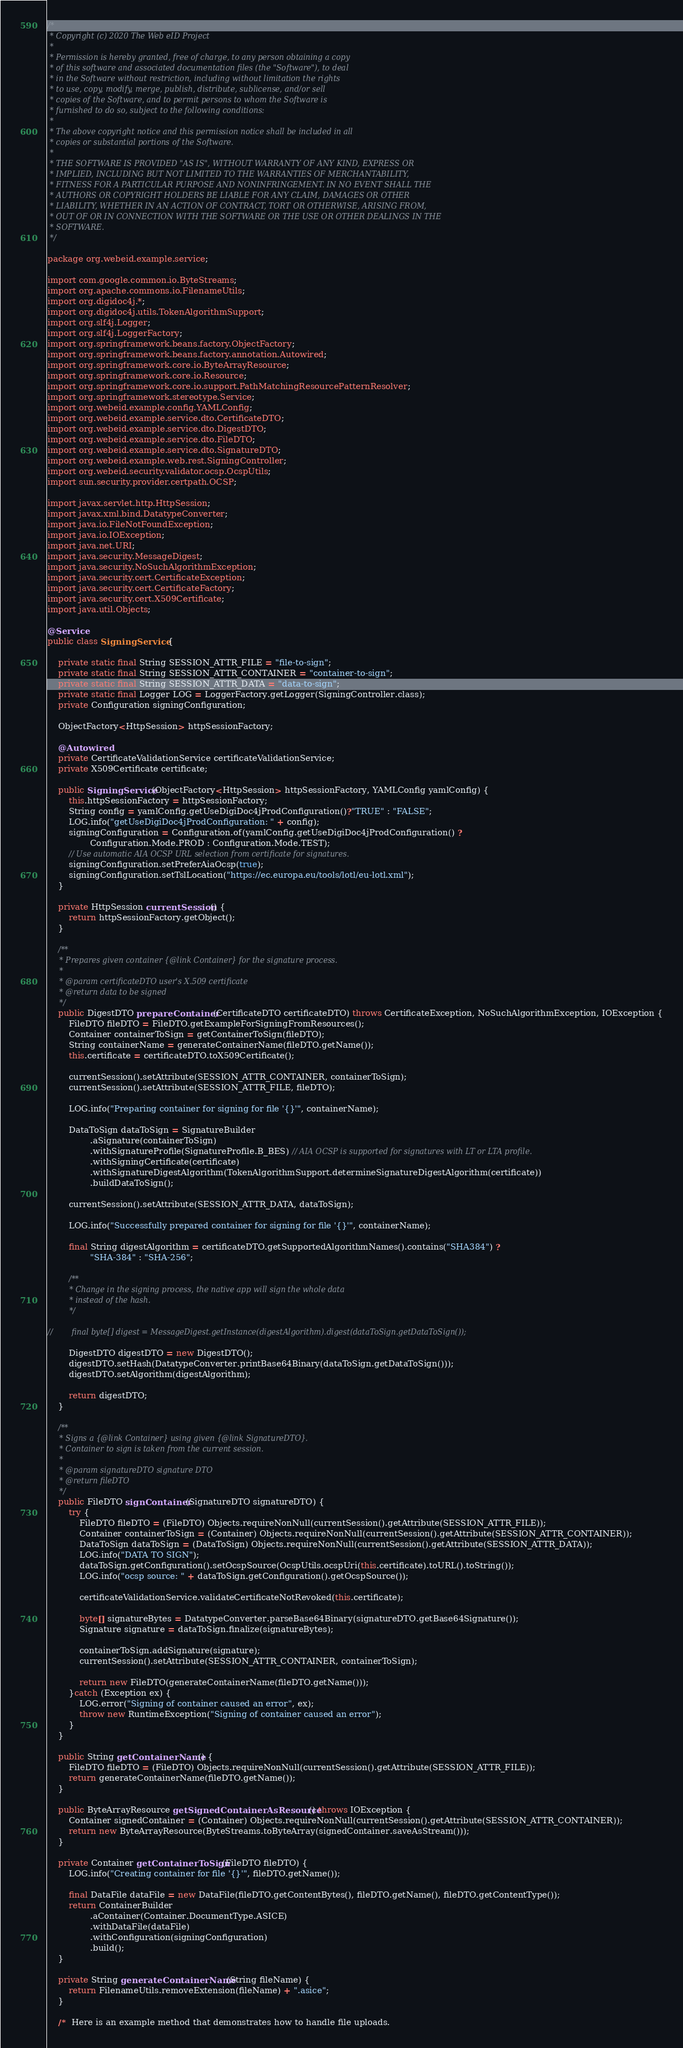<code> <loc_0><loc_0><loc_500><loc_500><_Java_>/*
 * Copyright (c) 2020 The Web eID Project
 *
 * Permission is hereby granted, free of charge, to any person obtaining a copy
 * of this software and associated documentation files (the "Software"), to deal
 * in the Software without restriction, including without limitation the rights
 * to use, copy, modify, merge, publish, distribute, sublicense, and/or sell
 * copies of the Software, and to permit persons to whom the Software is
 * furnished to do so, subject to the following conditions:
 *
 * The above copyright notice and this permission notice shall be included in all
 * copies or substantial portions of the Software.
 *
 * THE SOFTWARE IS PROVIDED "AS IS", WITHOUT WARRANTY OF ANY KIND, EXPRESS OR
 * IMPLIED, INCLUDING BUT NOT LIMITED TO THE WARRANTIES OF MERCHANTABILITY,
 * FITNESS FOR A PARTICULAR PURPOSE AND NONINFRINGEMENT. IN NO EVENT SHALL THE
 * AUTHORS OR COPYRIGHT HOLDERS BE LIABLE FOR ANY CLAIM, DAMAGES OR OTHER
 * LIABILITY, WHETHER IN AN ACTION OF CONTRACT, TORT OR OTHERWISE, ARISING FROM,
 * OUT OF OR IN CONNECTION WITH THE SOFTWARE OR THE USE OR OTHER DEALINGS IN THE
 * SOFTWARE.
 */

package org.webeid.example.service;

import com.google.common.io.ByteStreams;
import org.apache.commons.io.FilenameUtils;
import org.digidoc4j.*;
import org.digidoc4j.utils.TokenAlgorithmSupport;
import org.slf4j.Logger;
import org.slf4j.LoggerFactory;
import org.springframework.beans.factory.ObjectFactory;
import org.springframework.beans.factory.annotation.Autowired;
import org.springframework.core.io.ByteArrayResource;
import org.springframework.core.io.Resource;
import org.springframework.core.io.support.PathMatchingResourcePatternResolver;
import org.springframework.stereotype.Service;
import org.webeid.example.config.YAMLConfig;
import org.webeid.example.service.dto.CertificateDTO;
import org.webeid.example.service.dto.DigestDTO;
import org.webeid.example.service.dto.FileDTO;
import org.webeid.example.service.dto.SignatureDTO;
import org.webeid.example.web.rest.SigningController;
import org.webeid.security.validator.ocsp.OcspUtils;
import sun.security.provider.certpath.OCSP;

import javax.servlet.http.HttpSession;
import javax.xml.bind.DatatypeConverter;
import java.io.FileNotFoundException;
import java.io.IOException;
import java.net.URI;
import java.security.MessageDigest;
import java.security.NoSuchAlgorithmException;
import java.security.cert.CertificateException;
import java.security.cert.CertificateFactory;
import java.security.cert.X509Certificate;
import java.util.Objects;

@Service
public class SigningService {

    private static final String SESSION_ATTR_FILE = "file-to-sign";
    private static final String SESSION_ATTR_CONTAINER = "container-to-sign";
    private static final String SESSION_ATTR_DATA = "data-to-sign";
    private static final Logger LOG = LoggerFactory.getLogger(SigningController.class);
    private Configuration signingConfiguration;

    ObjectFactory<HttpSession> httpSessionFactory;

    @Autowired
    private CertificateValidationService certificateValidationService;
    private X509Certificate certificate;

    public SigningService(ObjectFactory<HttpSession> httpSessionFactory, YAMLConfig yamlConfig) {
        this.httpSessionFactory = httpSessionFactory;
        String config = yamlConfig.getUseDigiDoc4jProdConfiguration()?"TRUE" : "FALSE";
        LOG.info("getUseDigiDoc4jProdConfiguration: " + config);
        signingConfiguration = Configuration.of(yamlConfig.getUseDigiDoc4jProdConfiguration() ?
                Configuration.Mode.PROD : Configuration.Mode.TEST);
        // Use automatic AIA OCSP URL selection from certificate for signatures.
        signingConfiguration.setPreferAiaOcsp(true);
        signingConfiguration.setTslLocation("https://ec.europa.eu/tools/lotl/eu-lotl.xml");
    }

    private HttpSession currentSession() {
        return httpSessionFactory.getObject();
    }

    /**
     * Prepares given container {@link Container} for the signature process.
     *
     * @param certificateDTO user's X.509 certificate
     * @return data to be signed
     */
    public DigestDTO prepareContainer(CertificateDTO certificateDTO) throws CertificateException, NoSuchAlgorithmException, IOException {
        FileDTO fileDTO = FileDTO.getExampleForSigningFromResources();
        Container containerToSign = getContainerToSign(fileDTO);
        String containerName = generateContainerName(fileDTO.getName());
        this.certificate = certificateDTO.toX509Certificate();

        currentSession().setAttribute(SESSION_ATTR_CONTAINER, containerToSign);
        currentSession().setAttribute(SESSION_ATTR_FILE, fileDTO);

        LOG.info("Preparing container for signing for file '{}'", containerName);

        DataToSign dataToSign = SignatureBuilder
                .aSignature(containerToSign)
                .withSignatureProfile(SignatureProfile.B_BES) // AIA OCSP is supported for signatures with LT or LTA profile.
                .withSigningCertificate(certificate)
                .withSignatureDigestAlgorithm(TokenAlgorithmSupport.determineSignatureDigestAlgorithm(certificate))
                .buildDataToSign();

        currentSession().setAttribute(SESSION_ATTR_DATA, dataToSign);

        LOG.info("Successfully prepared container for signing for file '{}'", containerName);

        final String digestAlgorithm = certificateDTO.getSupportedAlgorithmNames().contains("SHA384") ?
                "SHA-384" : "SHA-256";

        /**
         * Change in the signing process, the native app will sign the whole data
         * instead of the hash.
         */

//        final byte[] digest = MessageDigest.getInstance(digestAlgorithm).digest(dataToSign.getDataToSign());

        DigestDTO digestDTO = new DigestDTO();
        digestDTO.setHash(DatatypeConverter.printBase64Binary(dataToSign.getDataToSign()));
        digestDTO.setAlgorithm(digestAlgorithm);

        return digestDTO;
    }

    /**
     * Signs a {@link Container} using given {@link SignatureDTO}.
     * Container to sign is taken from the current session.
     *
     * @param signatureDTO signature DTO
     * @return fileDTO
     */
    public FileDTO signContainer(SignatureDTO signatureDTO) {
        try {
            FileDTO fileDTO = (FileDTO) Objects.requireNonNull(currentSession().getAttribute(SESSION_ATTR_FILE));
            Container containerToSign = (Container) Objects.requireNonNull(currentSession().getAttribute(SESSION_ATTR_CONTAINER));
            DataToSign dataToSign = (DataToSign) Objects.requireNonNull(currentSession().getAttribute(SESSION_ATTR_DATA));
            LOG.info("DATA TO SIGN");
            dataToSign.getConfiguration().setOcspSource(OcspUtils.ocspUri(this.certificate).toURL().toString());
            LOG.info("ocsp source: " + dataToSign.getConfiguration().getOcspSource());

            certificateValidationService.validateCertificateNotRevoked(this.certificate);

            byte[] signatureBytes = DatatypeConverter.parseBase64Binary(signatureDTO.getBase64Signature());
            Signature signature = dataToSign.finalize(signatureBytes);

            containerToSign.addSignature(signature);
            currentSession().setAttribute(SESSION_ATTR_CONTAINER, containerToSign);

            return new FileDTO(generateContainerName(fileDTO.getName()));
        }catch (Exception ex) {
            LOG.error("Signing of container caused an error", ex);
            throw new RuntimeException("Signing of container caused an error");
        }
    }

    public String getContainerName() {
        FileDTO fileDTO = (FileDTO) Objects.requireNonNull(currentSession().getAttribute(SESSION_ATTR_FILE));
        return generateContainerName(fileDTO.getName());
    }

    public ByteArrayResource getSignedContainerAsResource() throws IOException {
        Container signedContainer = (Container) Objects.requireNonNull(currentSession().getAttribute(SESSION_ATTR_CONTAINER));
        return new ByteArrayResource(ByteStreams.toByteArray(signedContainer.saveAsStream()));
    }

    private Container getContainerToSign(FileDTO fileDTO) {
        LOG.info("Creating container for file '{}'", fileDTO.getName());

        final DataFile dataFile = new DataFile(fileDTO.getContentBytes(), fileDTO.getName(), fileDTO.getContentType());
        return ContainerBuilder
                .aContainer(Container.DocumentType.ASICE)
                .withDataFile(dataFile)
                .withConfiguration(signingConfiguration)
                .build();
    }

    private String generateContainerName(String fileName) {
        return FilenameUtils.removeExtension(fileName) + ".asice";
    }

    /*  Here is an example method that demonstrates how to handle file uploads.</code> 